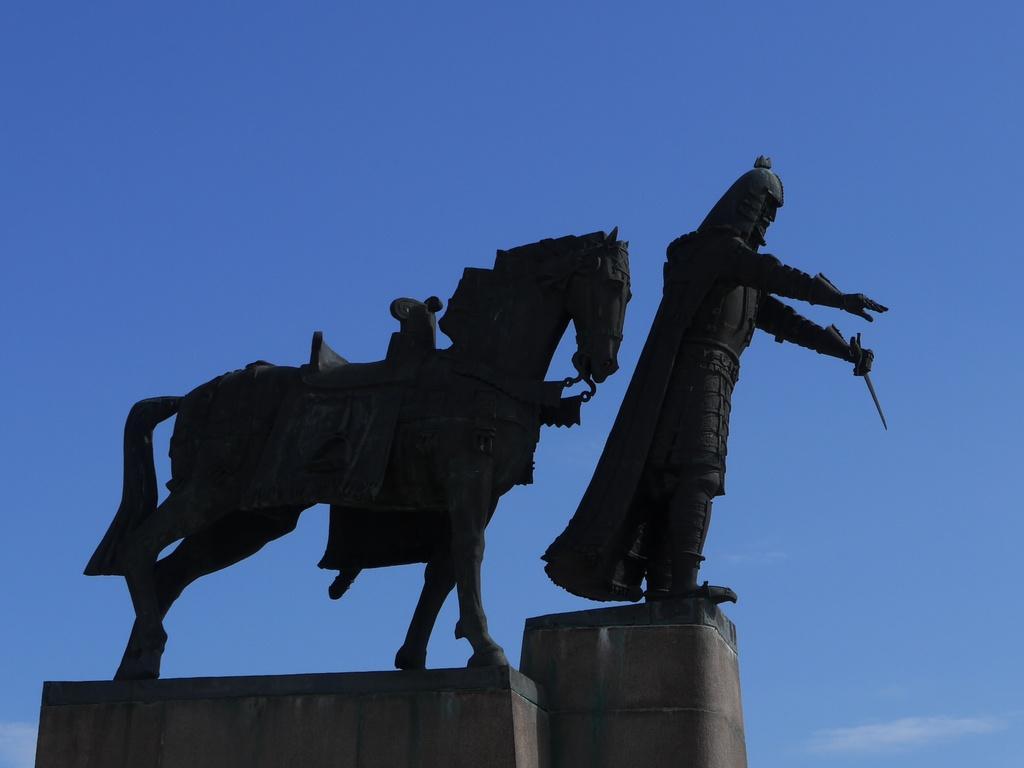How would you summarize this image in a sentence or two? In this image we can see the statues. On the backside we can see the sky which looks cloudy. 